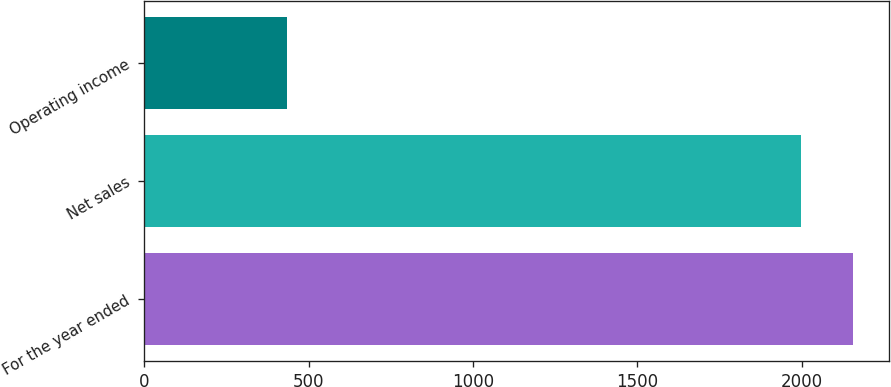<chart> <loc_0><loc_0><loc_500><loc_500><bar_chart><fcel>For the year ended<fcel>Net sales<fcel>Operating income<nl><fcel>2157<fcel>1999<fcel>435<nl></chart> 